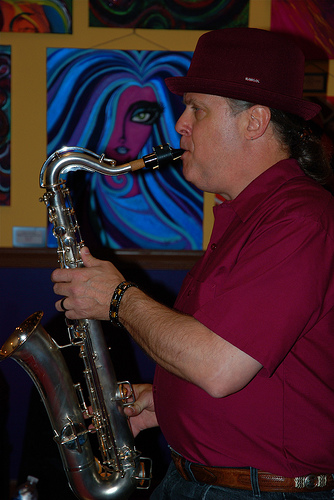<image>
Can you confirm if the girl is in front of the musician? No. The girl is not in front of the musician. The spatial positioning shows a different relationship between these objects. 